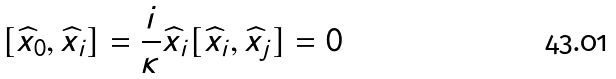Convert formula to latex. <formula><loc_0><loc_0><loc_500><loc_500>[ \widehat { x } _ { 0 } , \widehat { x } _ { i } ] = \frac { i } { \kappa } \widehat { x } _ { i } [ \widehat { x } _ { i } , \widehat { x } _ { j } ] = 0</formula> 